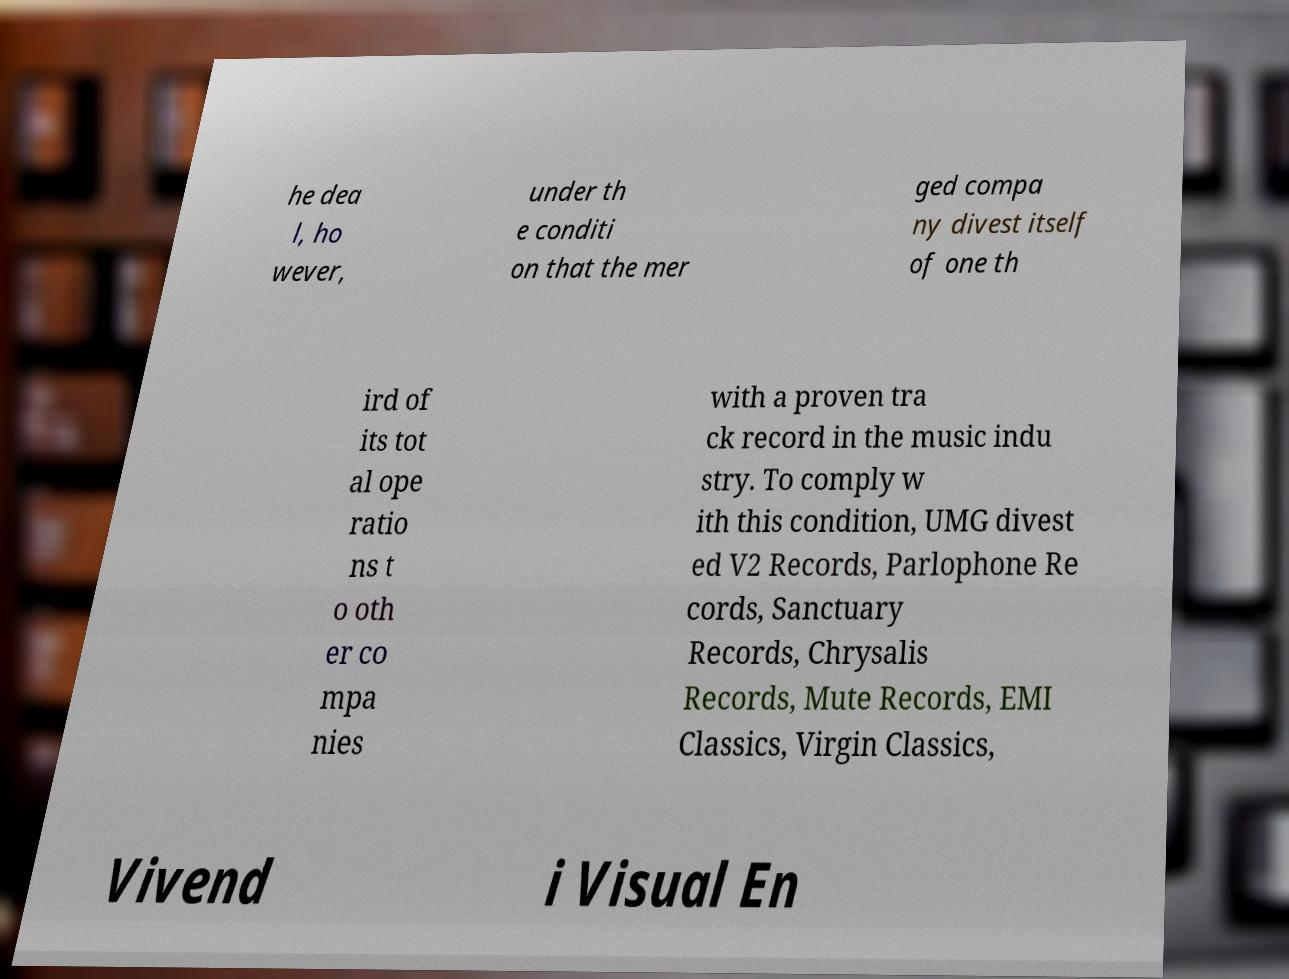There's text embedded in this image that I need extracted. Can you transcribe it verbatim? he dea l, ho wever, under th e conditi on that the mer ged compa ny divest itself of one th ird of its tot al ope ratio ns t o oth er co mpa nies with a proven tra ck record in the music indu stry. To comply w ith this condition, UMG divest ed V2 Records, Parlophone Re cords, Sanctuary Records, Chrysalis Records, Mute Records, EMI Classics, Virgin Classics, Vivend i Visual En 